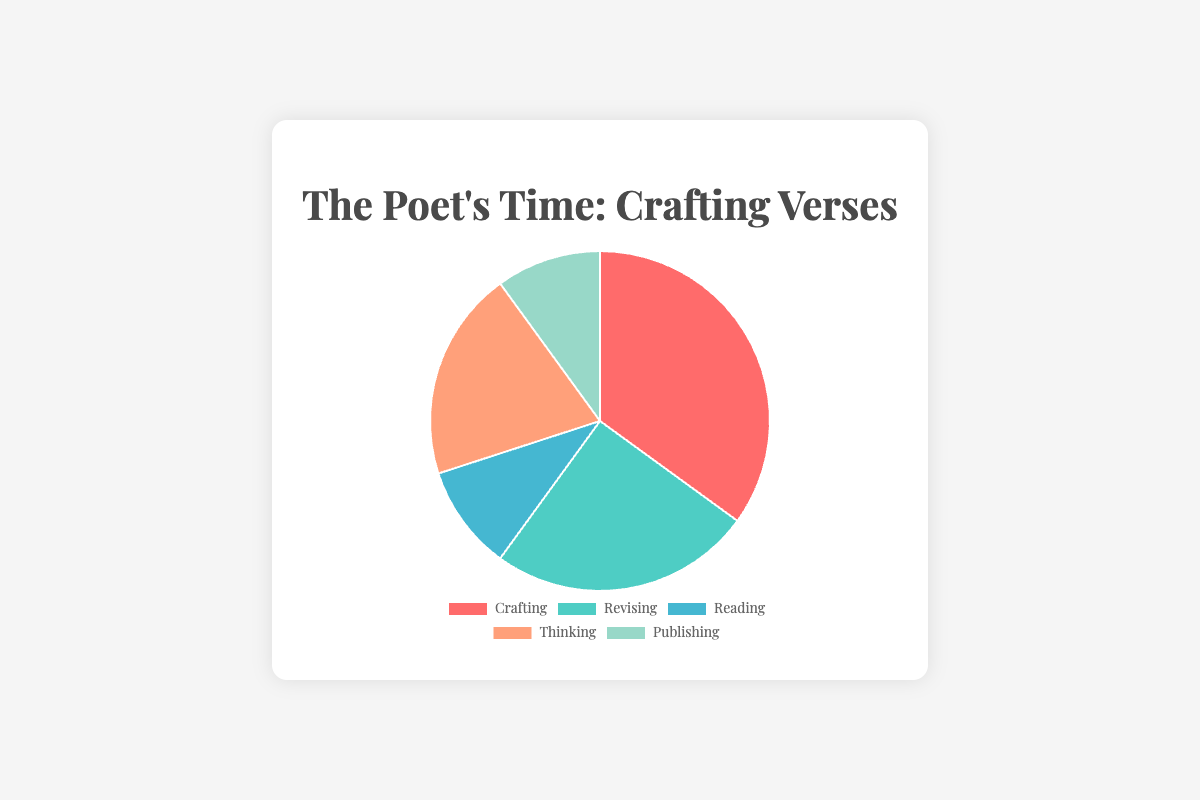What is the percentage of time spent on Reading? The slice labeled "Reading" shows a percentage value. Refer to this marker.
Answer: 10% Which stage takes up the largest portion of time? The pie chart section with the largest area or biggest percentage number indicates the stage that takes the most time. The "Crafting" portion is the largest.
Answer: Crafting How does the time spent on Thinking compare to the time spent on Publishing? Locate the slices labeled "Thinking" and "Publishing." The percentage for Thinking is 20%, while Publishing is 10%. Compare the two values.
Answer: Thinking takes twice as much time as Publishing What is the combined percentage of time spent on Crafting and Revising? Referring to the slices for Crafting (35%) and Revising (25%), add both percentages together.
Answer: 60% Which stages each take up 10% of the total time? Identify slices that each show "10%" as their labels. The slices for Reading and Publishing both show 10%.
Answer: Reading and Publishing What is the difference between the time spent on Crafting and Revising? Observe the slices for Crafting (35%) and Revising (25%). Subtract the percentage of Revising from Crafting.
Answer: 10% Is the time spent on Reading equal to or less than the time spent on Publishing? As both Reading and Publishing slices are labeled "10%," they are equal.
Answer: Equal By how much does the percentage of time spent on Revising exceed that spent on Thinking? Slices for Revising (25%) and Thinking (20%) should be compared. Subtract the percentage for Thinking from that of Revising.
Answer: 5% Which two stages combined have the same percentage as the Crafting stage? Seeing that Crafting takes 35%, identify any two stages whose combined total equals 35%. Revising (25%) and Reading (10%) together equal 35%.
Answer: Revising and Reading 